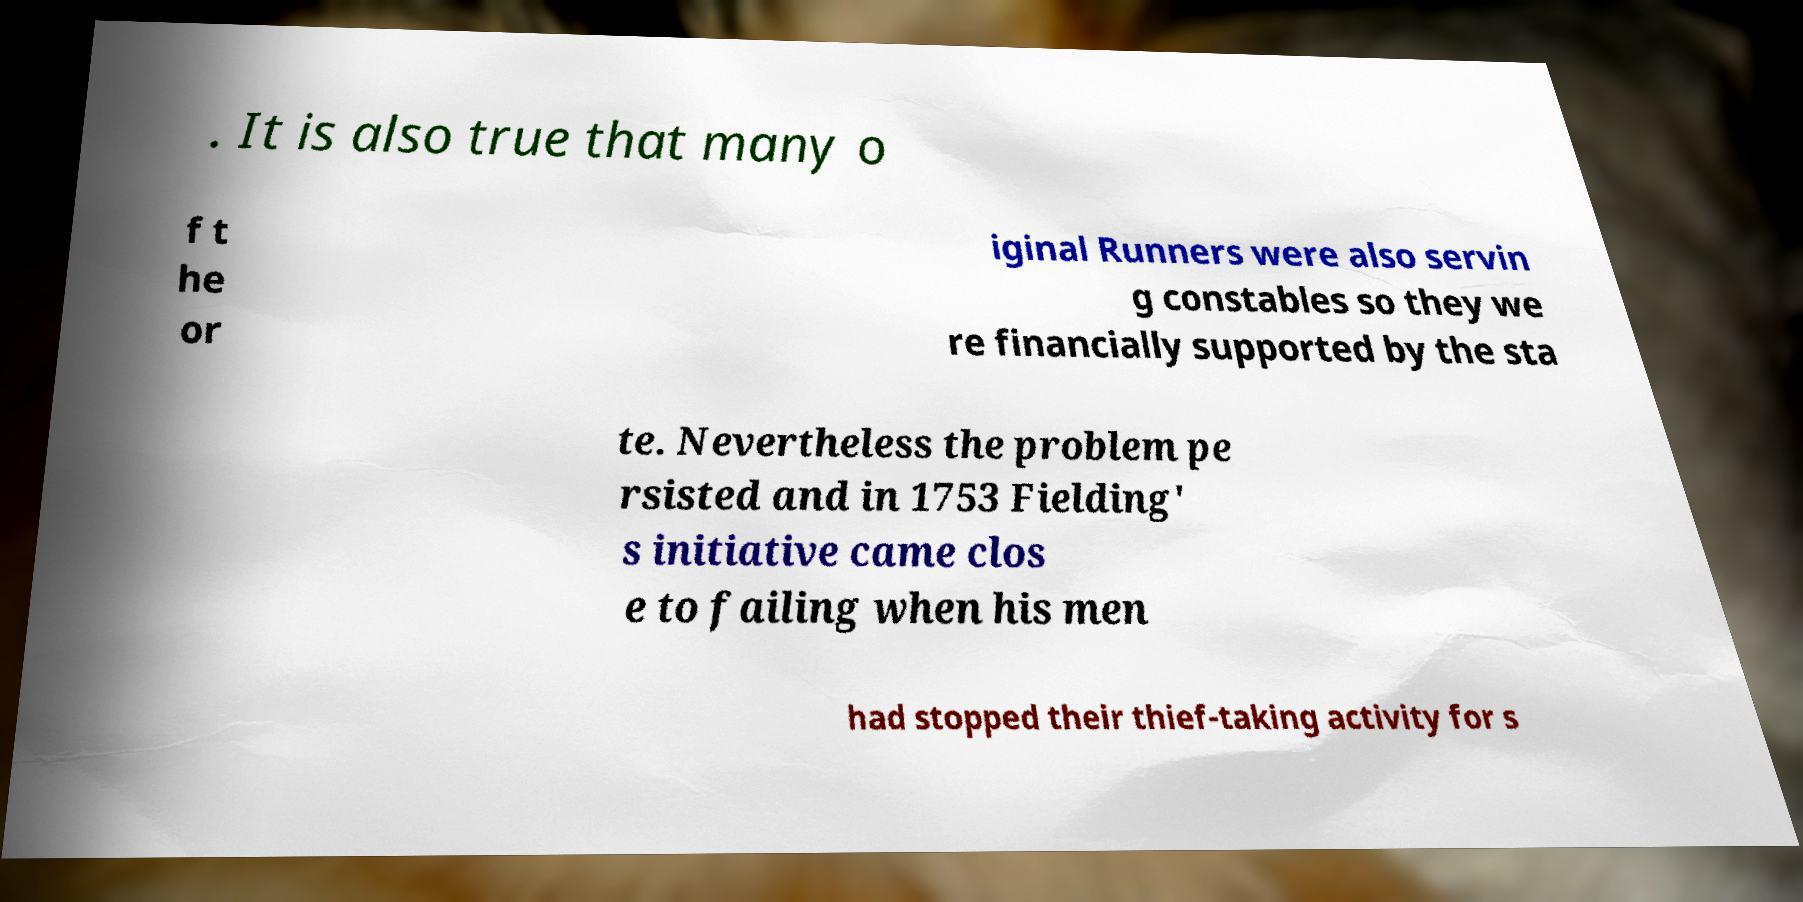I need the written content from this picture converted into text. Can you do that? . It is also true that many o f t he or iginal Runners were also servin g constables so they we re financially supported by the sta te. Nevertheless the problem pe rsisted and in 1753 Fielding' s initiative came clos e to failing when his men had stopped their thief-taking activity for s 